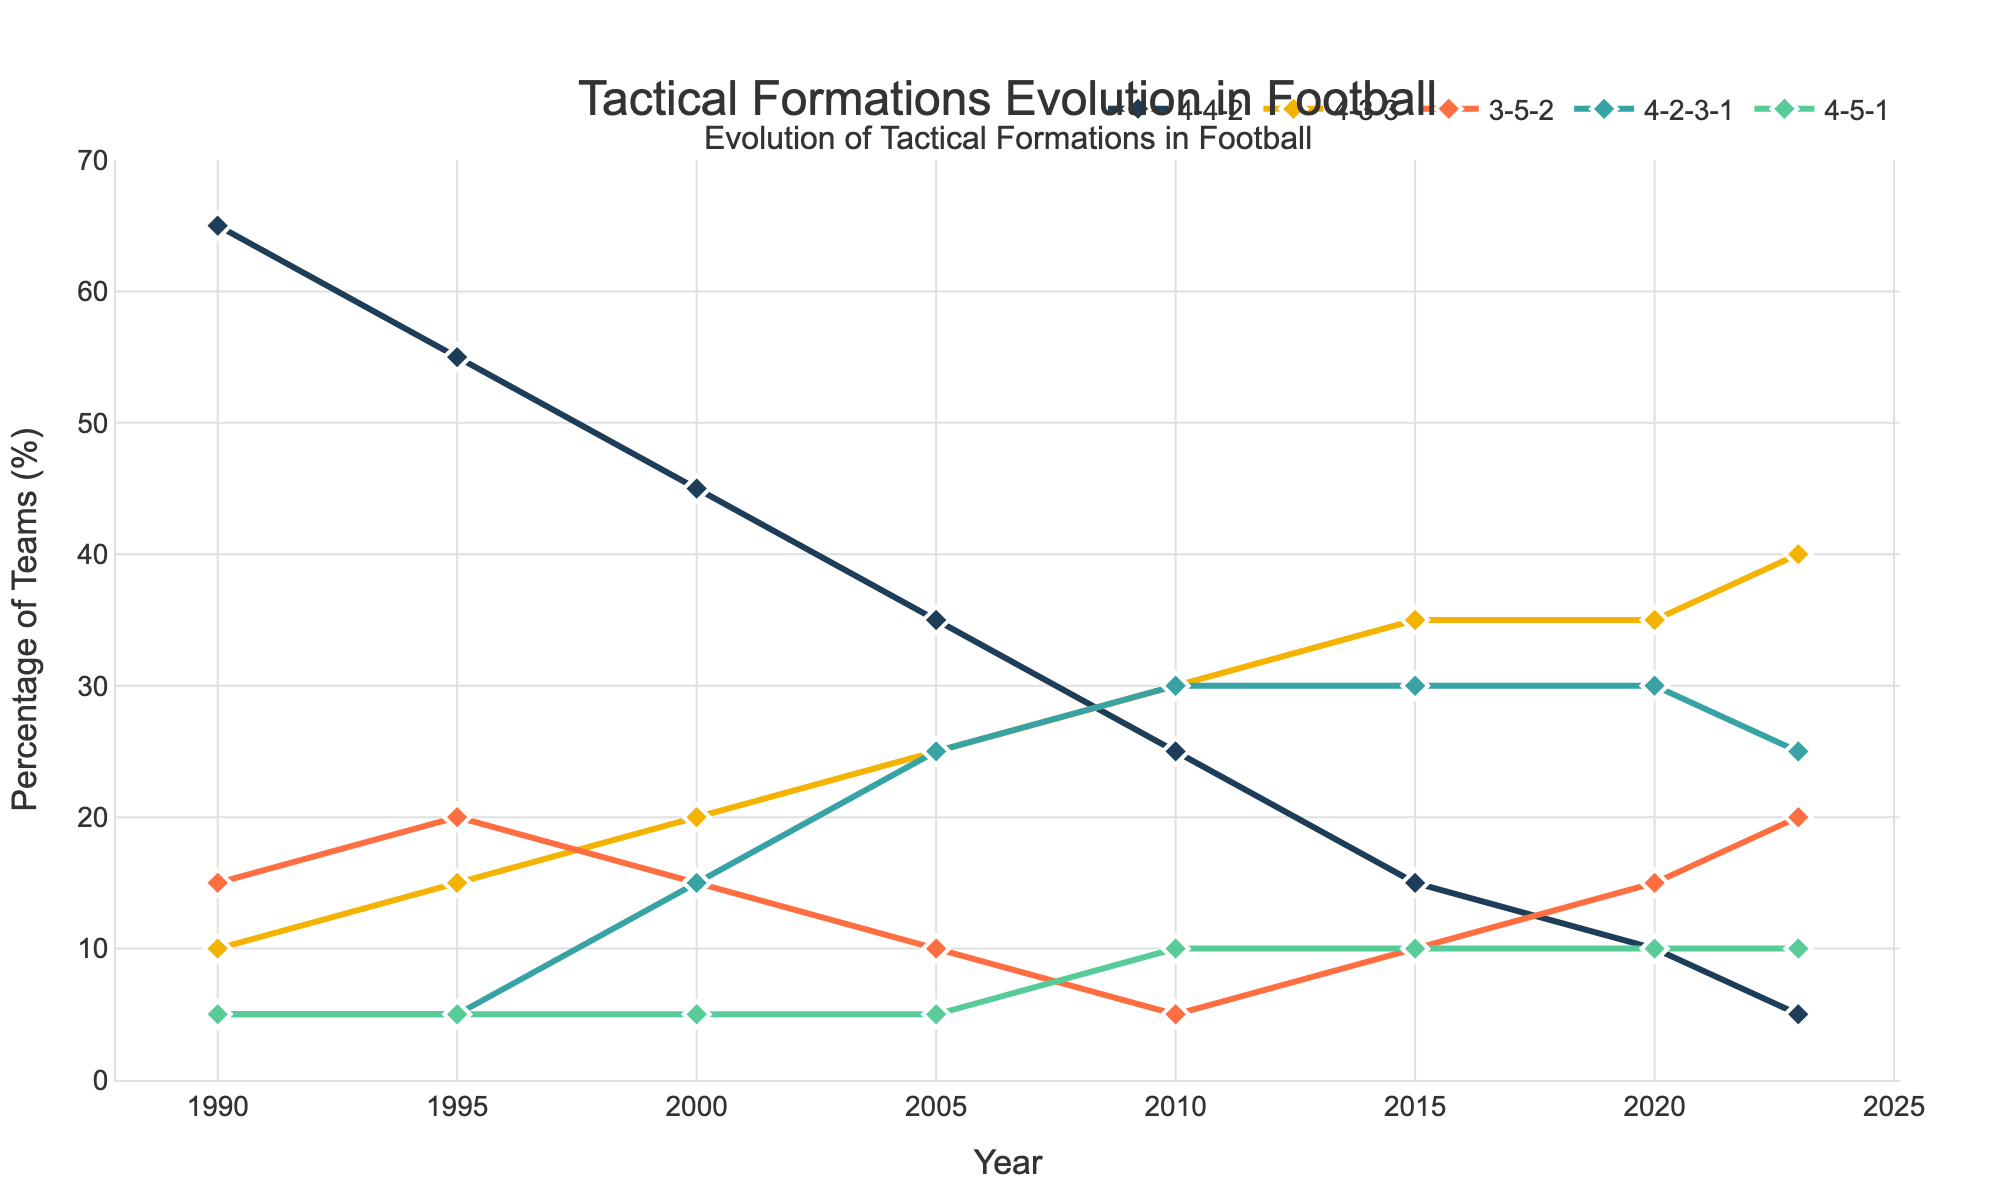What's the most popular formation in 2023? By looking at the trend lines for the year 2023, the formation with the highest value is 4-3-3.
Answer: 4-3-3 How has the popularity of 4-4-2 changed from 1990 to 2023? In 1990, 65% of teams used 4-4-2, while in 2023, only 5% of teams used it.
Answer: Decreased Which formation showed the most significant increase in popularity from 1990 to 2023? By comparing the starting and ending points of each trend line, 4-3-3 increased from 10% in 1990 to 40% in 2023.
Answer: 4-3-3 What is the average percentage of teams using 4-2-3-1 from 2000 to 2020? The percentages for 4-2-3-1 in 2000, 2005, 2010, 2015, and 2020 are 15%, 25%, 30%, 30%, and 30%, respectively. Summing these values gives 130%, and the average over 5 data points is 130/5 = 26%.
Answer: 26% Between 4-3-3 and 3-5-2, which had a higher usage percentage in 2010? In 2010, the percentage values are 4-3-3 at 30% and 3-5-2 at 5%.
Answer: 4-3-3 What's the trend of the 4-5-1 formation from 1990 to 2023? The line for 4-5-1 starts at 5% in 1990, stays at 5% until 2005, then rises to 10% by 2010 and remains stable till 2023.
Answer: Increasing then Stable Which formations showed a decline in popularity between 2000 and 2010? By comparing the values in 2000 and 2010, 4-4-2 decreased from 45% to 25% and 3-5-2 decreased from 15% to 5%.
Answer: 4-4-2, 3-5-2 In which year did the 4-2-3-1 formation first surpass 4-4-2 in popularity? By examining the values, in 2005, 4-4-2 was 35% and 4-2-3-1 was 25%. In 2010, 4-4-2 was 25% and 4-2-3-1 was 30%. So, 2010 is the first year when 4-2-3-1 surpassed 4-4-2.
Answer: 2010 